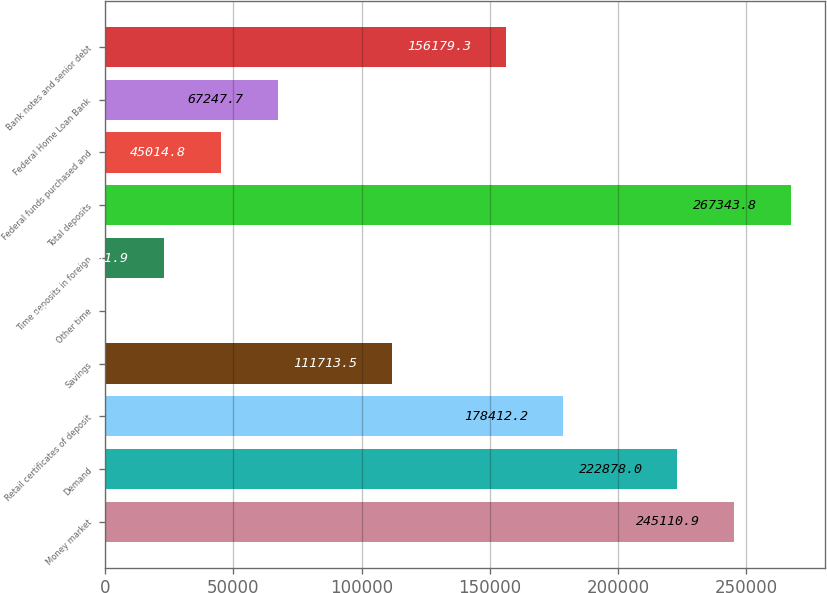Convert chart. <chart><loc_0><loc_0><loc_500><loc_500><bar_chart><fcel>Money market<fcel>Demand<fcel>Retail certificates of deposit<fcel>Savings<fcel>Other time<fcel>Time deposits in foreign<fcel>Total deposits<fcel>Federal funds purchased and<fcel>Federal Home Loan Bank<fcel>Bank notes and senior debt<nl><fcel>245111<fcel>222878<fcel>178412<fcel>111714<fcel>549<fcel>22781.9<fcel>267344<fcel>45014.8<fcel>67247.7<fcel>156179<nl></chart> 